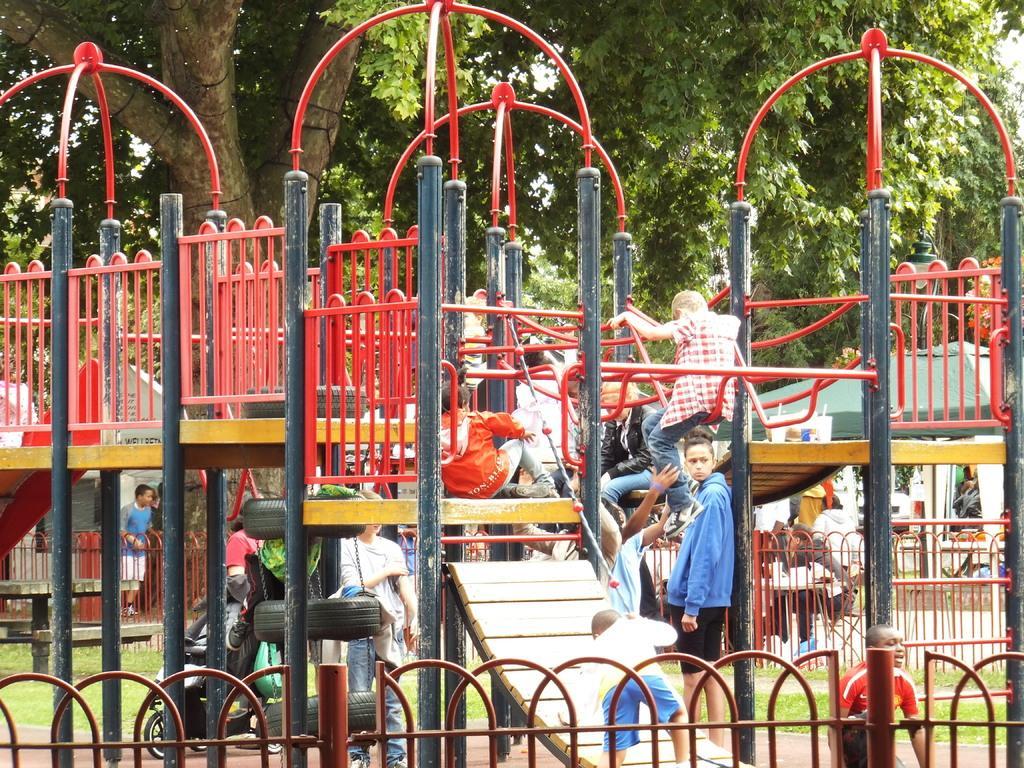How would you summarize this image in a sentence or two? In this picture we can see inside of the playground. In the front we can see some swings and red pipes. In the front there is a boy wearing a blue jacket standing and looking to the camera. Behind we can see huge tree and in the front bottom side there is a red iron railing grill. 